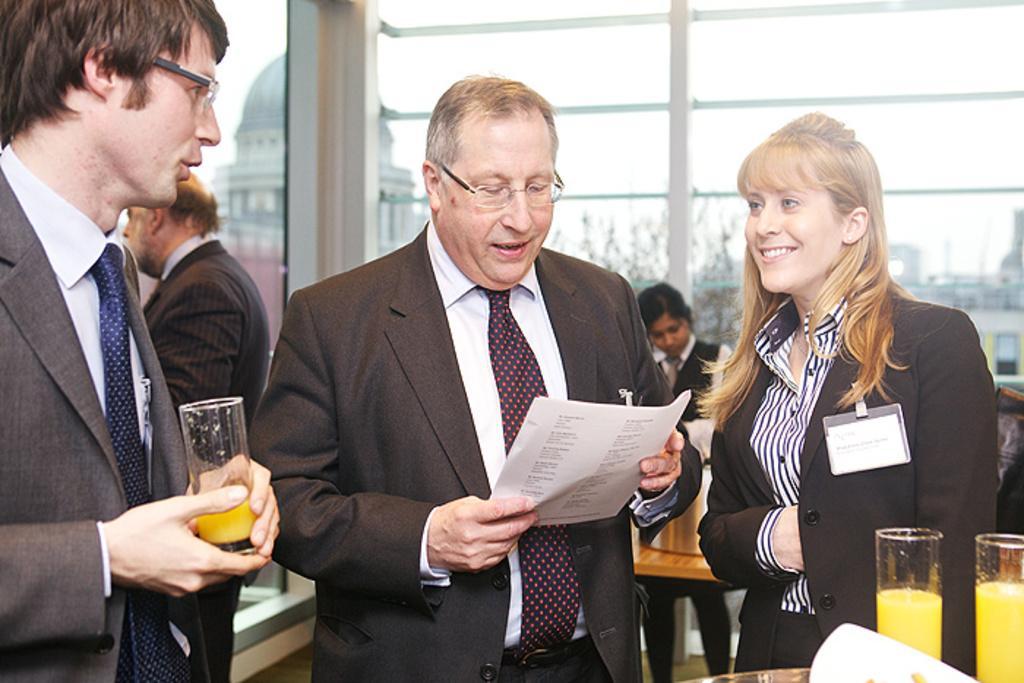Can you describe this image briefly? This image is taken indoors. In the background there is a glass wall and through the wall we can see there are a few buildings. At the bottom of the image there is a table with two glasses of juice on it. On the left side of the image a man is standing on the floor and holding a glass with juice in his hands and another man is standing on the floor. In the middle of the image a man is standing on the floor and holding papers in his hands. On the right side of the image two women are standing on the floor and there is a table with a few things on it. 